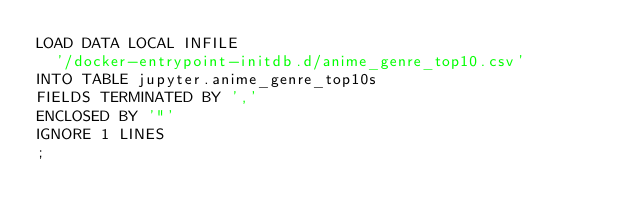Convert code to text. <code><loc_0><loc_0><loc_500><loc_500><_SQL_>LOAD DATA LOCAL INFILE
  '/docker-entrypoint-initdb.d/anime_genre_top10.csv'
INTO TABLE jupyter.anime_genre_top10s
FIELDS TERMINATED BY ','
ENCLOSED BY '"'
IGNORE 1 LINES
;
</code> 